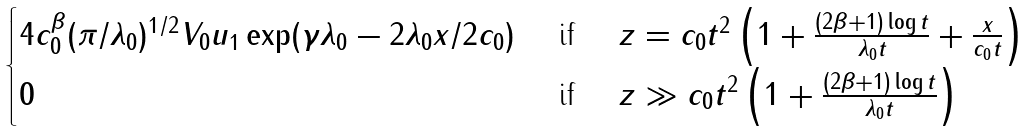Convert formula to latex. <formula><loc_0><loc_0><loc_500><loc_500>\begin{cases} 4 c _ { 0 } ^ { \beta } ( \pi / \lambda _ { 0 } ) ^ { 1 / 2 } V _ { 0 } u _ { 1 } \exp ( \gamma \lambda _ { 0 } - 2 \lambda _ { 0 } x / 2 c _ { 0 } ) & \text { if } \quad z = c _ { 0 } t ^ { 2 } \left ( 1 + \frac { ( 2 \beta + 1 ) \log t } { \lambda _ { 0 } t } + \frac { x } { c _ { 0 } t } \right ) \\ 0 & \text { if } \quad z \gg c _ { 0 } t ^ { 2 } \left ( 1 + \frac { ( 2 \beta + 1 ) \log t } { \lambda _ { 0 } t } \right ) \end{cases}</formula> 